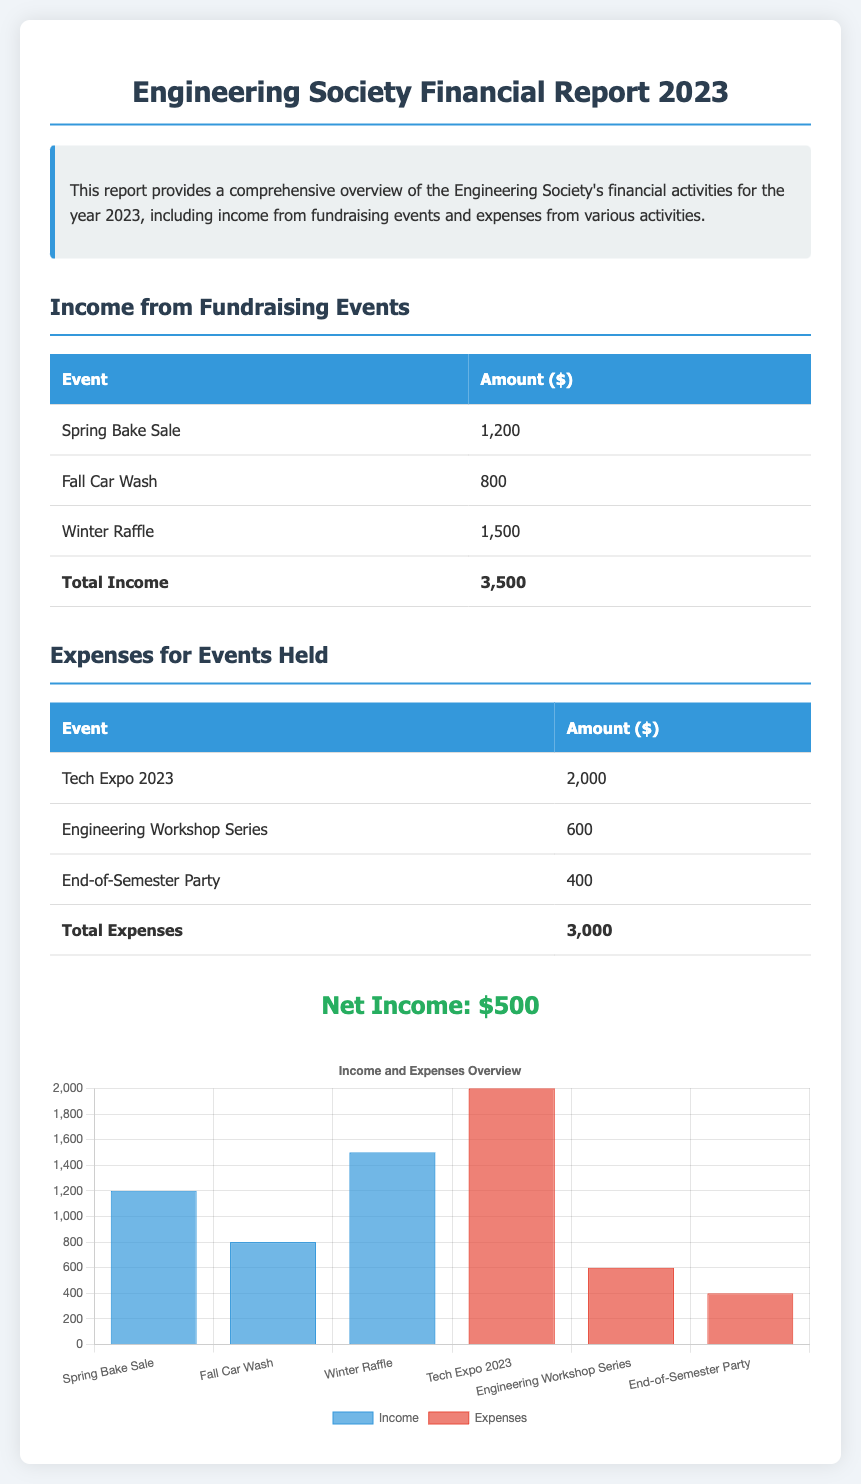What is the total income from fundraising events? The total income from fundraising events is listed as the sum of individual events in the report, which is $1200 + $800 + $1500.
Answer: $3500 What is the total expenses for events held? The total expenses is provided at the bottom of the expenses table, calculated as $2000 + $600 + $400.
Answer: $3000 How much money was raised from the Winter Raffle? The amount raised from the Winter Raffle is specified in the income table.
Answer: $1500 What is the net income reported in the document? The net income is calculated as total income minus total expenses, which is $3500 - $3000.
Answer: $500 What is the amount spent on the Tech Expo 2023? The expense for the Tech Expo 2023 is given in the expenses table.
Answer: $2000 Which fundraising event generated the least income? The income from each fundraising event is provided; the event with the least income is identified.
Answer: Fall Car Wash What does the bar chart illustrate? The bar chart represents the income and expenses related to various events, specifically their financial overview.
Answer: Income and Expenses Overview How many events are listed under fundraising activities? The number of events in the fundraising section is counted in the income table.
Answer: 3 What color represents expenses in the chart? The color used to represent expenses in the chart is specified in the chart dataset.
Answer: Red 